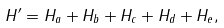Convert formula to latex. <formula><loc_0><loc_0><loc_500><loc_500>H ^ { \prime } = H _ { a } + H _ { b } + H _ { c } + H _ { d } + H _ { e } ,</formula> 